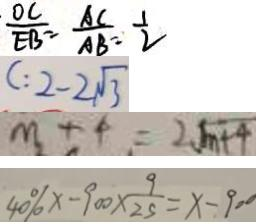Convert formula to latex. <formula><loc_0><loc_0><loc_500><loc_500>\frac { O C } { E B } = \frac { A C } { A B } = \frac { 1 } { 2 } 
 C : 2 - 2 \sqrt { 3 } 
 m + 4 = 2 \sqrt { m + 4 } 
 4 0 \% x - 9 0 0 \times \frac { 9 } { 2 5 } = x - 9 0 0</formula> 